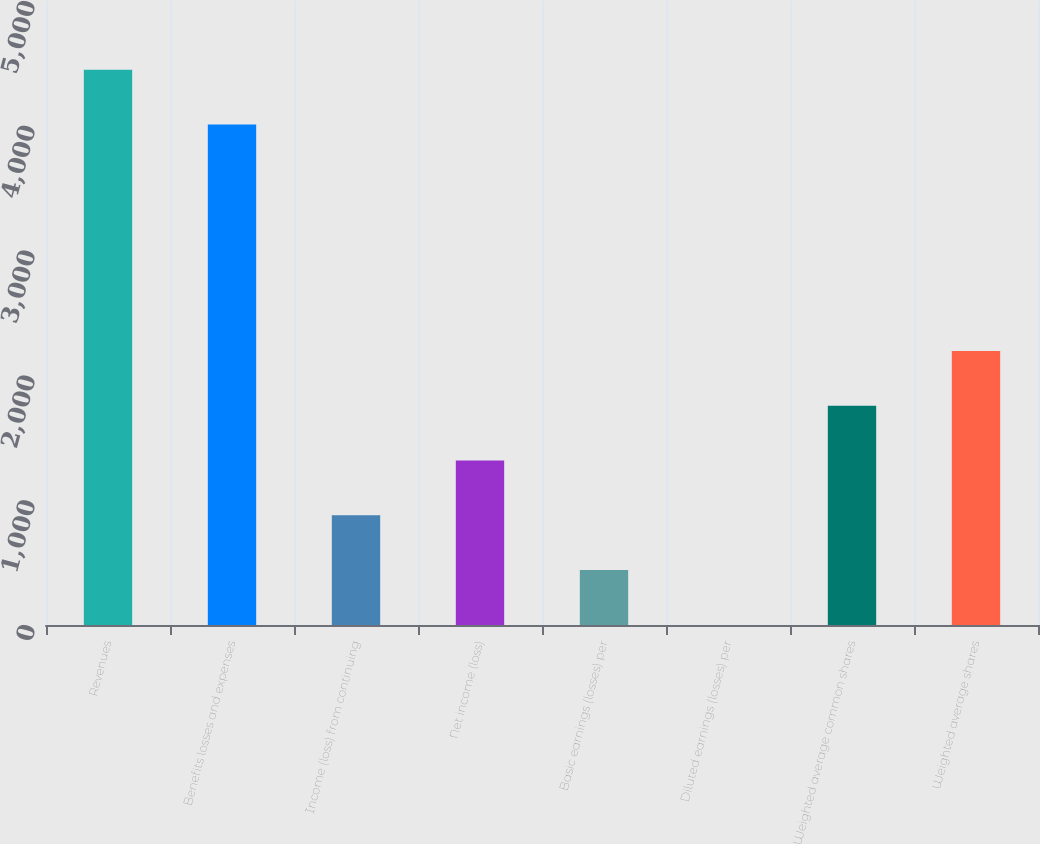<chart> <loc_0><loc_0><loc_500><loc_500><bar_chart><fcel>Revenues<fcel>Benefits losses and expenses<fcel>Income (loss) from continuing<fcel>Net income (loss)<fcel>Basic earnings (losses) per<fcel>Diluted earnings (losses) per<fcel>Weighted average common shares<fcel>Weighted average shares<nl><fcel>4449.02<fcel>4010<fcel>878.83<fcel>1317.85<fcel>439.81<fcel>0.79<fcel>1756.87<fcel>2195.89<nl></chart> 